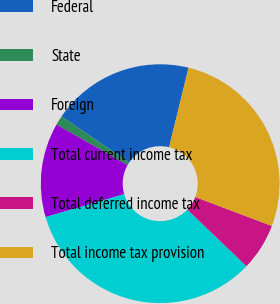Convert chart to OTSL. <chart><loc_0><loc_0><loc_500><loc_500><pie_chart><fcel>Federal<fcel>State<fcel>Foreign<fcel>Total current income tax<fcel>Total deferred income tax<fcel>Total income tax provision<nl><fcel>19.29%<fcel>1.28%<fcel>12.76%<fcel>33.33%<fcel>6.38%<fcel>26.95%<nl></chart> 